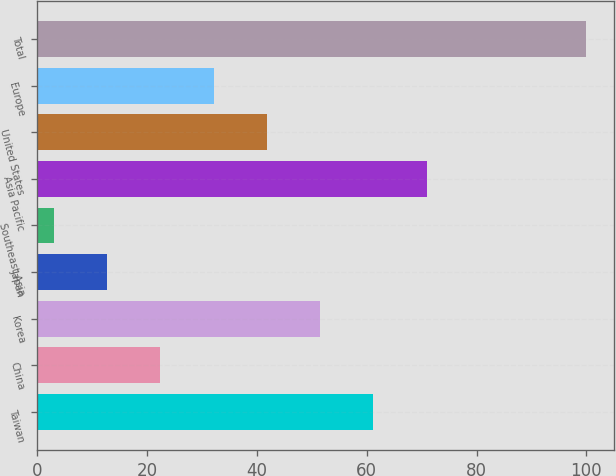Convert chart to OTSL. <chart><loc_0><loc_0><loc_500><loc_500><bar_chart><fcel>Taiwan<fcel>China<fcel>Korea<fcel>Japan<fcel>Southeast Asia<fcel>Asia Pacific<fcel>United States<fcel>Europe<fcel>Total<nl><fcel>61.2<fcel>22.4<fcel>51.5<fcel>12.7<fcel>3<fcel>70.9<fcel>41.8<fcel>32.1<fcel>100<nl></chart> 